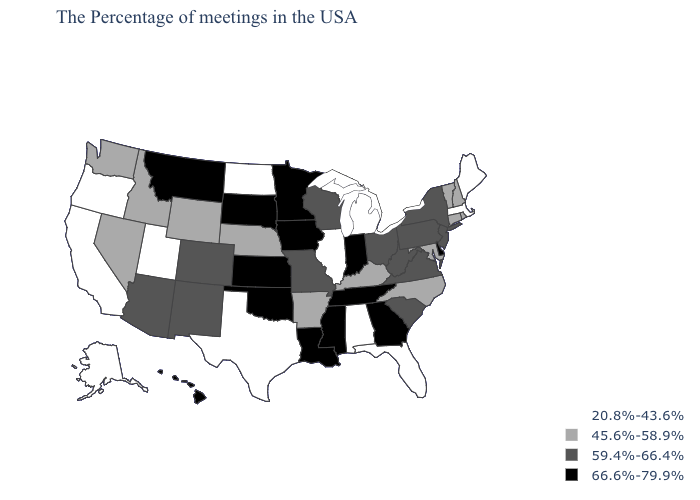Among the states that border Rhode Island , which have the lowest value?
Keep it brief. Massachusetts. What is the value of Mississippi?
Be succinct. 66.6%-79.9%. Name the states that have a value in the range 45.6%-58.9%?
Give a very brief answer. Rhode Island, New Hampshire, Vermont, Connecticut, Maryland, North Carolina, Kentucky, Arkansas, Nebraska, Wyoming, Idaho, Nevada, Washington. What is the value of Pennsylvania?
Concise answer only. 59.4%-66.4%. What is the value of New York?
Quick response, please. 59.4%-66.4%. What is the value of Kansas?
Write a very short answer. 66.6%-79.9%. Name the states that have a value in the range 20.8%-43.6%?
Short answer required. Maine, Massachusetts, Florida, Michigan, Alabama, Illinois, Texas, North Dakota, Utah, California, Oregon, Alaska. Does Maine have the lowest value in the USA?
Give a very brief answer. Yes. Name the states that have a value in the range 45.6%-58.9%?
Answer briefly. Rhode Island, New Hampshire, Vermont, Connecticut, Maryland, North Carolina, Kentucky, Arkansas, Nebraska, Wyoming, Idaho, Nevada, Washington. Name the states that have a value in the range 45.6%-58.9%?
Keep it brief. Rhode Island, New Hampshire, Vermont, Connecticut, Maryland, North Carolina, Kentucky, Arkansas, Nebraska, Wyoming, Idaho, Nevada, Washington. What is the lowest value in the USA?
Answer briefly. 20.8%-43.6%. Name the states that have a value in the range 66.6%-79.9%?
Short answer required. Delaware, Georgia, Indiana, Tennessee, Mississippi, Louisiana, Minnesota, Iowa, Kansas, Oklahoma, South Dakota, Montana, Hawaii. What is the value of North Carolina?
Concise answer only. 45.6%-58.9%. Is the legend a continuous bar?
Short answer required. No. 